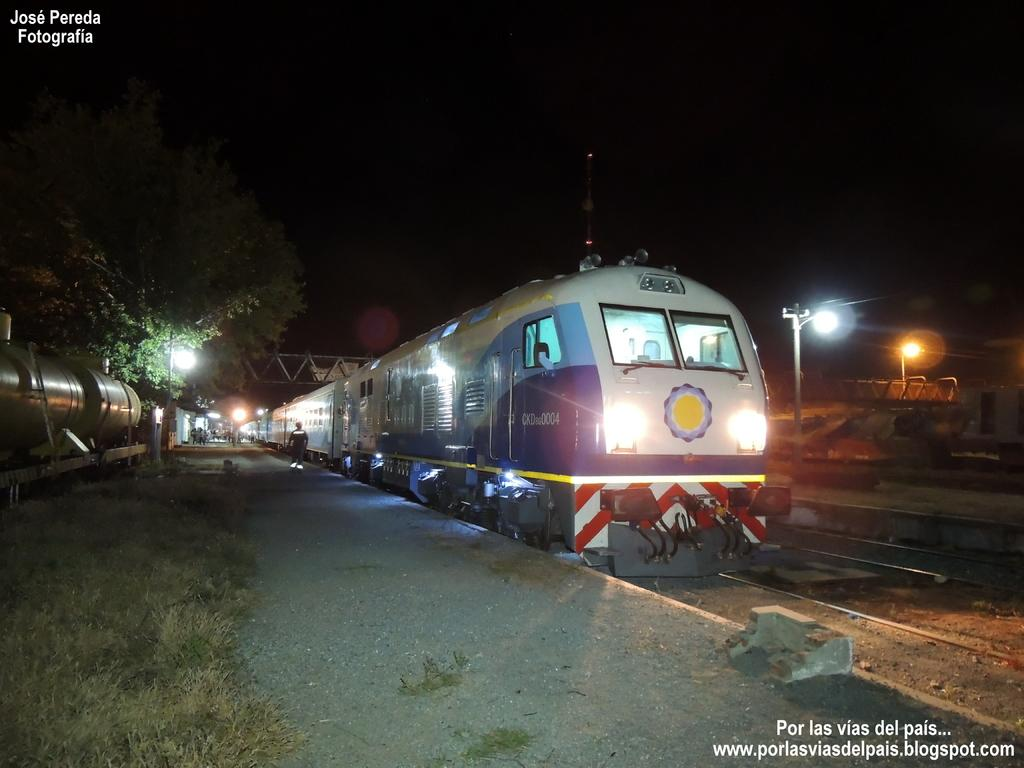What is the main subject of the image? The main subject of the image is a train. What can be seen alongside the train in the image? There is a train track in the image. What type of terrain is visible next to the train track? There is a path next to the train track. What type of vegetation is visible in the image? There is grass visible in the image. What can be seen in the background of the image? There are trees, lights, and people in the background of the image. What type of force can be seen pushing the train in the image? There is no force pushing the train visible in the image; it is stationary on the train track. Can you see any rifles in the image? There are no rifles present in the image. 